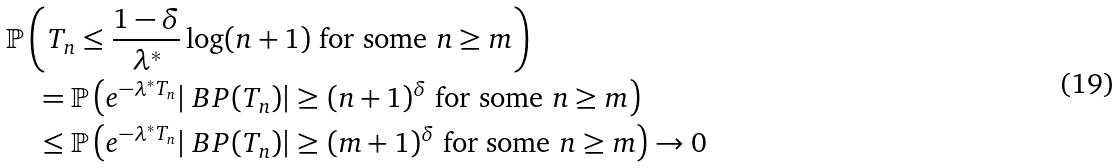Convert formula to latex. <formula><loc_0><loc_0><loc_500><loc_500>& \mathbb { P } \left ( T _ { n } \leq \frac { 1 - \delta } { \lambda ^ { * } } \log ( n + 1 ) \text { for some } n \geq m \right ) \\ & \quad = \mathbb { P } \left ( e ^ { - \lambda ^ { * } T _ { n } } | \ B P ( T _ { n } ) | \geq ( n + 1 ) ^ { \delta } \text { for some } n \geq m \right ) \\ & \quad \leq \mathbb { P } \left ( e ^ { - \lambda ^ { * } T _ { n } } | \ B P ( T _ { n } ) | \geq ( m + 1 ) ^ { \delta } \text { for some } n \geq m \right ) \rightarrow 0</formula> 